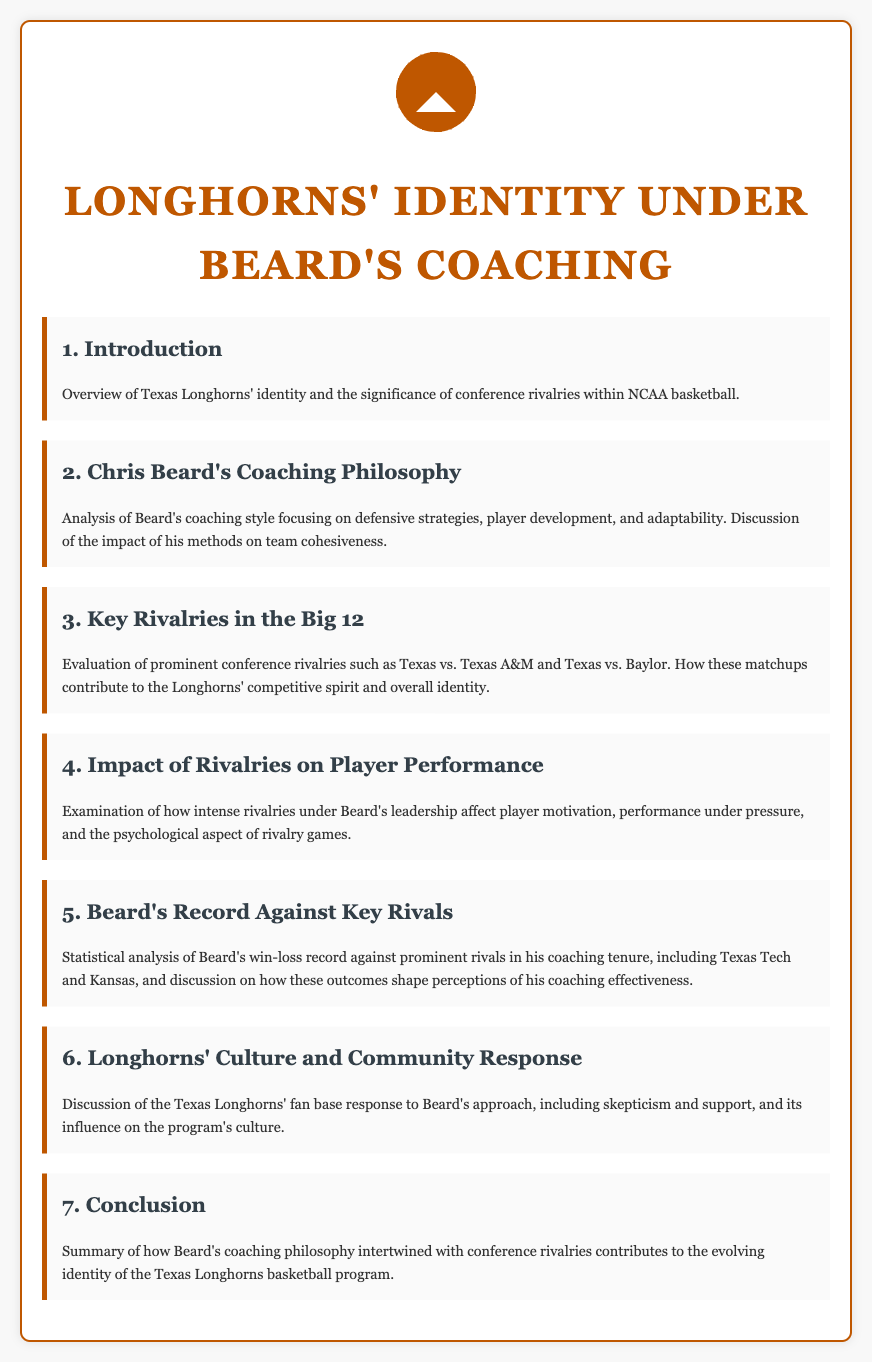What is the title of the document? The title of the document is stated prominently at the top.
Answer: Longhorns' Identity under Beard's Coaching Who is the coach discussed in the document? The document specifically mentions a coach throughout its sections.
Answer: Chris Beard What are the key rivalries mentioned? The document refers to specific rivalries in relation to Texas Longhorns.
Answer: Texas vs. Texas A&M and Texas vs. Baylor How does the document describe Beard's coaching style? The document provides a focused analysis of Beard's coaching style in one section.
Answer: Defensive strategies, player development, adaptability What aspect of player performance is examined in the document? The document looks at how rivalries affect a particular quality in players.
Answer: Motivation What type of fan response is discussed? The document discusses the fans' attitude towards Beard's coaching style.
Answer: Skepticism and support What is the conclusion about Beard's coaching philosophy? The conclusion summarizes the overall influence of Beard's coaching philosophy on the Longhorns' identity.
Answer: Evolving identity of the Texas Longhorns basketball program 